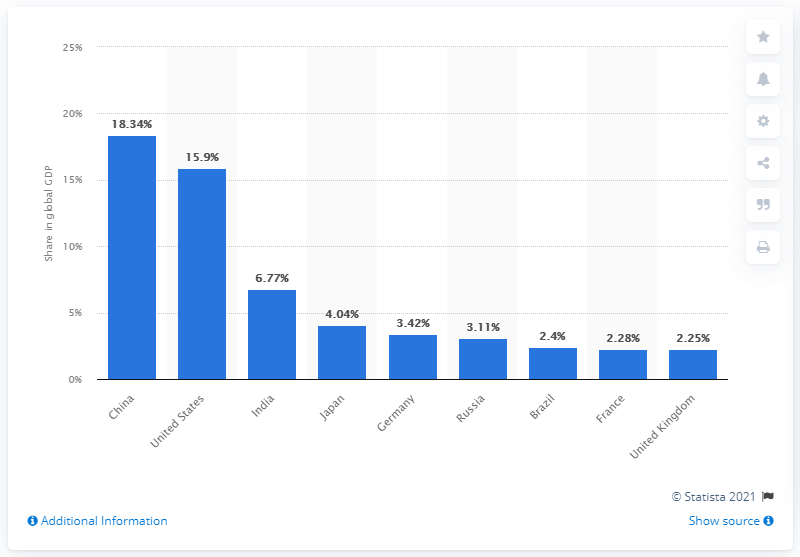Give some essential details in this illustration. In 2020, China's share of the global gross domestic product was 18.34%. 